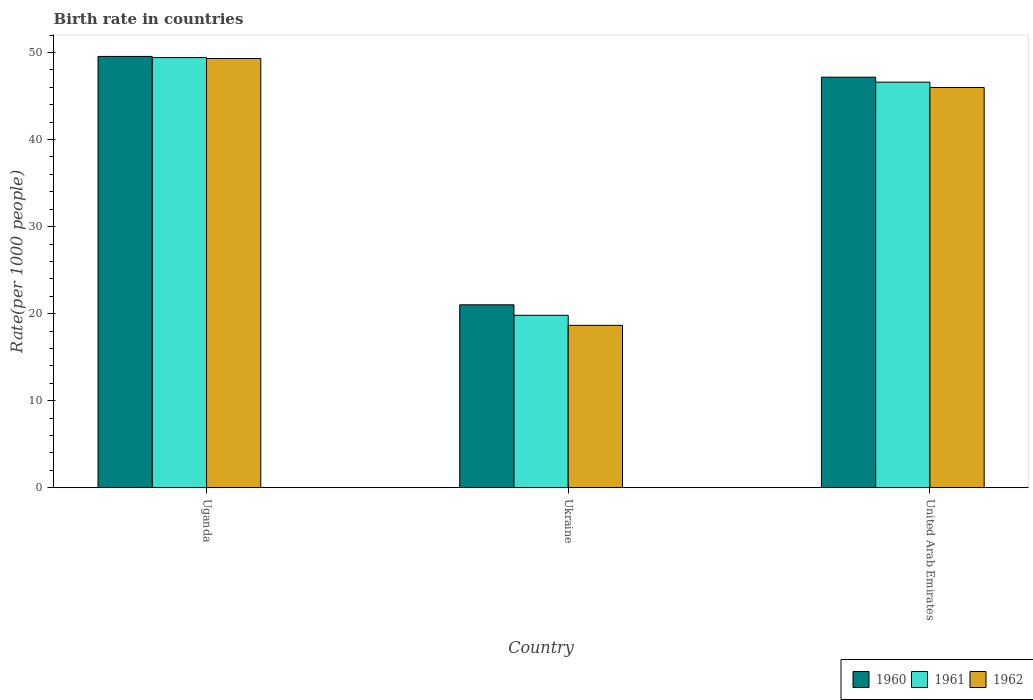How many bars are there on the 2nd tick from the right?
Make the answer very short. 3. What is the label of the 3rd group of bars from the left?
Provide a succinct answer. United Arab Emirates. What is the birth rate in 1961 in Uganda?
Offer a very short reply. 49.43. Across all countries, what is the maximum birth rate in 1961?
Provide a short and direct response. 49.43. Across all countries, what is the minimum birth rate in 1961?
Offer a terse response. 19.81. In which country was the birth rate in 1960 maximum?
Your response must be concise. Uganda. In which country was the birth rate in 1960 minimum?
Ensure brevity in your answer.  Ukraine. What is the total birth rate in 1961 in the graph?
Make the answer very short. 115.84. What is the difference between the birth rate in 1960 in Uganda and that in United Arab Emirates?
Your answer should be very brief. 2.39. What is the difference between the birth rate in 1960 in Uganda and the birth rate in 1962 in United Arab Emirates?
Your answer should be very brief. 3.57. What is the average birth rate in 1960 per country?
Ensure brevity in your answer.  39.25. What is the difference between the birth rate of/in 1961 and birth rate of/in 1962 in United Arab Emirates?
Keep it short and to the point. 0.61. What is the ratio of the birth rate in 1960 in Uganda to that in United Arab Emirates?
Keep it short and to the point. 1.05. What is the difference between the highest and the second highest birth rate in 1960?
Your answer should be compact. 28.55. What is the difference between the highest and the lowest birth rate in 1961?
Ensure brevity in your answer.  29.62. In how many countries, is the birth rate in 1961 greater than the average birth rate in 1961 taken over all countries?
Your answer should be very brief. 2. What does the 1st bar from the left in Uganda represents?
Ensure brevity in your answer.  1960. Are all the bars in the graph horizontal?
Your answer should be compact. No. What is the difference between two consecutive major ticks on the Y-axis?
Your response must be concise. 10. Does the graph contain any zero values?
Keep it short and to the point. No. Where does the legend appear in the graph?
Keep it short and to the point. Bottom right. How are the legend labels stacked?
Keep it short and to the point. Horizontal. What is the title of the graph?
Offer a terse response. Birth rate in countries. What is the label or title of the Y-axis?
Make the answer very short. Rate(per 1000 people). What is the Rate(per 1000 people) of 1960 in Uganda?
Ensure brevity in your answer.  49.56. What is the Rate(per 1000 people) in 1961 in Uganda?
Provide a succinct answer. 49.43. What is the Rate(per 1000 people) in 1962 in Uganda?
Provide a short and direct response. 49.32. What is the Rate(per 1000 people) in 1960 in Ukraine?
Keep it short and to the point. 21.01. What is the Rate(per 1000 people) of 1961 in Ukraine?
Provide a short and direct response. 19.81. What is the Rate(per 1000 people) in 1962 in Ukraine?
Keep it short and to the point. 18.65. What is the Rate(per 1000 people) in 1960 in United Arab Emirates?
Make the answer very short. 47.17. What is the Rate(per 1000 people) in 1961 in United Arab Emirates?
Provide a succinct answer. 46.6. What is the Rate(per 1000 people) of 1962 in United Arab Emirates?
Give a very brief answer. 45.99. Across all countries, what is the maximum Rate(per 1000 people) of 1960?
Ensure brevity in your answer.  49.56. Across all countries, what is the maximum Rate(per 1000 people) in 1961?
Offer a terse response. 49.43. Across all countries, what is the maximum Rate(per 1000 people) of 1962?
Provide a succinct answer. 49.32. Across all countries, what is the minimum Rate(per 1000 people) in 1960?
Your response must be concise. 21.01. Across all countries, what is the minimum Rate(per 1000 people) in 1961?
Offer a terse response. 19.81. Across all countries, what is the minimum Rate(per 1000 people) in 1962?
Your answer should be compact. 18.65. What is the total Rate(per 1000 people) of 1960 in the graph?
Offer a terse response. 117.74. What is the total Rate(per 1000 people) of 1961 in the graph?
Provide a short and direct response. 115.84. What is the total Rate(per 1000 people) of 1962 in the graph?
Keep it short and to the point. 113.96. What is the difference between the Rate(per 1000 people) in 1960 in Uganda and that in Ukraine?
Provide a succinct answer. 28.55. What is the difference between the Rate(per 1000 people) of 1961 in Uganda and that in Ukraine?
Provide a succinct answer. 29.62. What is the difference between the Rate(per 1000 people) of 1962 in Uganda and that in Ukraine?
Give a very brief answer. 30.66. What is the difference between the Rate(per 1000 people) of 1960 in Uganda and that in United Arab Emirates?
Offer a terse response. 2.39. What is the difference between the Rate(per 1000 people) of 1961 in Uganda and that in United Arab Emirates?
Your response must be concise. 2.83. What is the difference between the Rate(per 1000 people) in 1962 in Uganda and that in United Arab Emirates?
Provide a succinct answer. 3.33. What is the difference between the Rate(per 1000 people) in 1960 in Ukraine and that in United Arab Emirates?
Your response must be concise. -26.16. What is the difference between the Rate(per 1000 people) in 1961 in Ukraine and that in United Arab Emirates?
Your answer should be very brief. -26.79. What is the difference between the Rate(per 1000 people) of 1962 in Ukraine and that in United Arab Emirates?
Your answer should be very brief. -27.33. What is the difference between the Rate(per 1000 people) in 1960 in Uganda and the Rate(per 1000 people) in 1961 in Ukraine?
Offer a very short reply. 29.75. What is the difference between the Rate(per 1000 people) in 1960 in Uganda and the Rate(per 1000 people) in 1962 in Ukraine?
Provide a succinct answer. 30.9. What is the difference between the Rate(per 1000 people) in 1961 in Uganda and the Rate(per 1000 people) in 1962 in Ukraine?
Your response must be concise. 30.77. What is the difference between the Rate(per 1000 people) in 1960 in Uganda and the Rate(per 1000 people) in 1961 in United Arab Emirates?
Offer a very short reply. 2.96. What is the difference between the Rate(per 1000 people) in 1960 in Uganda and the Rate(per 1000 people) in 1962 in United Arab Emirates?
Provide a succinct answer. 3.57. What is the difference between the Rate(per 1000 people) in 1961 in Uganda and the Rate(per 1000 people) in 1962 in United Arab Emirates?
Provide a short and direct response. 3.44. What is the difference between the Rate(per 1000 people) of 1960 in Ukraine and the Rate(per 1000 people) of 1961 in United Arab Emirates?
Your answer should be very brief. -25.59. What is the difference between the Rate(per 1000 people) in 1960 in Ukraine and the Rate(per 1000 people) in 1962 in United Arab Emirates?
Make the answer very short. -24.98. What is the difference between the Rate(per 1000 people) in 1961 in Ukraine and the Rate(per 1000 people) in 1962 in United Arab Emirates?
Offer a very short reply. -26.18. What is the average Rate(per 1000 people) in 1960 per country?
Give a very brief answer. 39.25. What is the average Rate(per 1000 people) in 1961 per country?
Make the answer very short. 38.61. What is the average Rate(per 1000 people) in 1962 per country?
Keep it short and to the point. 37.99. What is the difference between the Rate(per 1000 people) of 1960 and Rate(per 1000 people) of 1961 in Uganda?
Provide a short and direct response. 0.13. What is the difference between the Rate(per 1000 people) in 1960 and Rate(per 1000 people) in 1962 in Uganda?
Provide a succinct answer. 0.24. What is the difference between the Rate(per 1000 people) in 1961 and Rate(per 1000 people) in 1962 in Uganda?
Offer a very short reply. 0.11. What is the difference between the Rate(per 1000 people) of 1960 and Rate(per 1000 people) of 1961 in Ukraine?
Your response must be concise. 1.2. What is the difference between the Rate(per 1000 people) of 1960 and Rate(per 1000 people) of 1962 in Ukraine?
Provide a short and direct response. 2.36. What is the difference between the Rate(per 1000 people) in 1961 and Rate(per 1000 people) in 1962 in Ukraine?
Give a very brief answer. 1.15. What is the difference between the Rate(per 1000 people) in 1960 and Rate(per 1000 people) in 1961 in United Arab Emirates?
Keep it short and to the point. 0.57. What is the difference between the Rate(per 1000 people) of 1960 and Rate(per 1000 people) of 1962 in United Arab Emirates?
Your answer should be compact. 1.18. What is the difference between the Rate(per 1000 people) of 1961 and Rate(per 1000 people) of 1962 in United Arab Emirates?
Your response must be concise. 0.61. What is the ratio of the Rate(per 1000 people) of 1960 in Uganda to that in Ukraine?
Keep it short and to the point. 2.36. What is the ratio of the Rate(per 1000 people) of 1961 in Uganda to that in Ukraine?
Provide a short and direct response. 2.5. What is the ratio of the Rate(per 1000 people) in 1962 in Uganda to that in Ukraine?
Your answer should be compact. 2.64. What is the ratio of the Rate(per 1000 people) in 1960 in Uganda to that in United Arab Emirates?
Provide a succinct answer. 1.05. What is the ratio of the Rate(per 1000 people) of 1961 in Uganda to that in United Arab Emirates?
Your response must be concise. 1.06. What is the ratio of the Rate(per 1000 people) of 1962 in Uganda to that in United Arab Emirates?
Your response must be concise. 1.07. What is the ratio of the Rate(per 1000 people) in 1960 in Ukraine to that in United Arab Emirates?
Offer a very short reply. 0.45. What is the ratio of the Rate(per 1000 people) in 1961 in Ukraine to that in United Arab Emirates?
Offer a very short reply. 0.42. What is the ratio of the Rate(per 1000 people) in 1962 in Ukraine to that in United Arab Emirates?
Offer a terse response. 0.41. What is the difference between the highest and the second highest Rate(per 1000 people) in 1960?
Make the answer very short. 2.39. What is the difference between the highest and the second highest Rate(per 1000 people) of 1961?
Offer a terse response. 2.83. What is the difference between the highest and the second highest Rate(per 1000 people) of 1962?
Offer a very short reply. 3.33. What is the difference between the highest and the lowest Rate(per 1000 people) in 1960?
Provide a succinct answer. 28.55. What is the difference between the highest and the lowest Rate(per 1000 people) of 1961?
Give a very brief answer. 29.62. What is the difference between the highest and the lowest Rate(per 1000 people) of 1962?
Provide a succinct answer. 30.66. 